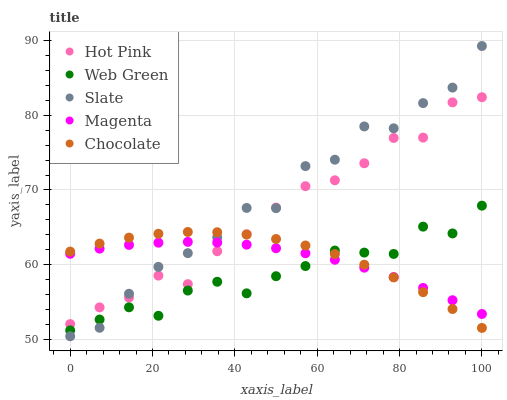Does Web Green have the minimum area under the curve?
Answer yes or no. Yes. Does Slate have the maximum area under the curve?
Answer yes or no. Yes. Does Hot Pink have the minimum area under the curve?
Answer yes or no. No. Does Hot Pink have the maximum area under the curve?
Answer yes or no. No. Is Magenta the smoothest?
Answer yes or no. Yes. Is Slate the roughest?
Answer yes or no. Yes. Is Hot Pink the smoothest?
Answer yes or no. No. Is Hot Pink the roughest?
Answer yes or no. No. Does Slate have the lowest value?
Answer yes or no. Yes. Does Hot Pink have the lowest value?
Answer yes or no. No. Does Slate have the highest value?
Answer yes or no. Yes. Does Hot Pink have the highest value?
Answer yes or no. No. Is Web Green less than Hot Pink?
Answer yes or no. Yes. Is Hot Pink greater than Web Green?
Answer yes or no. Yes. Does Chocolate intersect Web Green?
Answer yes or no. Yes. Is Chocolate less than Web Green?
Answer yes or no. No. Is Chocolate greater than Web Green?
Answer yes or no. No. Does Web Green intersect Hot Pink?
Answer yes or no. No. 